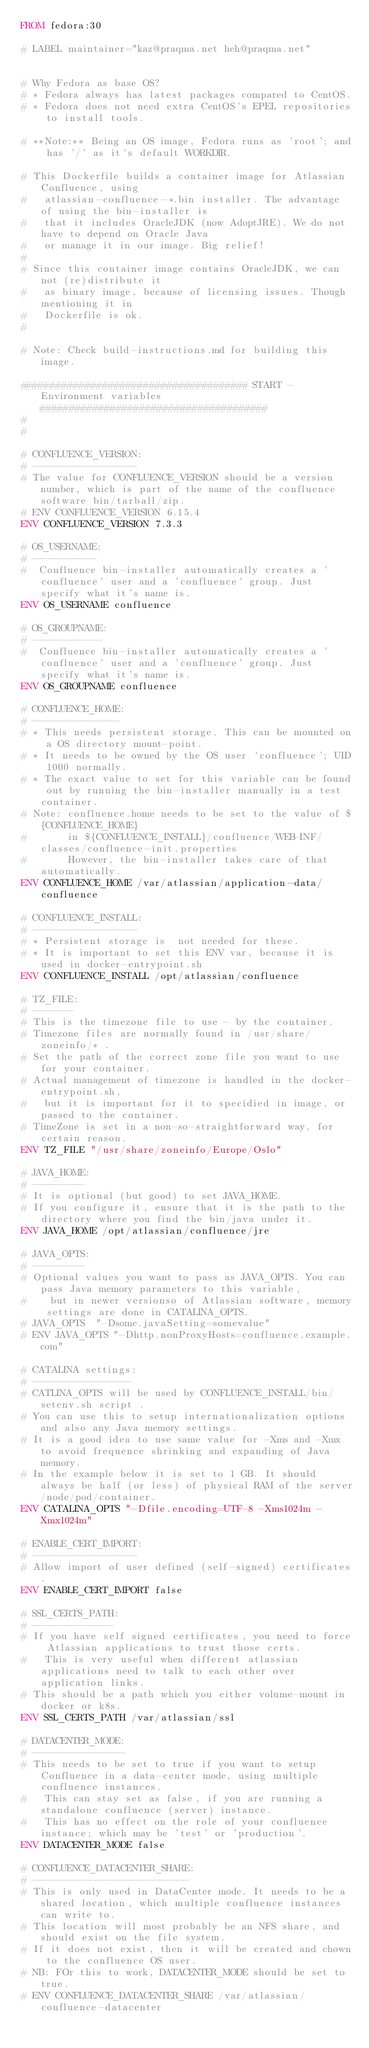<code> <loc_0><loc_0><loc_500><loc_500><_Dockerfile_>FROM fedora:30

# LABEL maintainer="kaz@praqma.net heh@praqma.net"


# Why Fedora as base OS?
# * Fedora always has latest packages compared to CentOS.
# * Fedora does not need extra CentOS's EPEL repositories to install tools.

# **Note:** Being an OS image, Fedora runs as 'root'; and has '/' as it's default WORKDIR.

# This Dockerfile builds a container image for Atlassian Confluence, using 
#   atlassian-confluence-*.bin installer. The advantage of using the bin-installer is
#   that it includes OracleJDK (now AdoptJRE). We do not have to depend on Oracle Java 
#   or manage it in our image. Big relief!
#
# Since this container image contains OracleJDK, we can not (re)distribute it 
#   as binary image, because of licensing issues. Though mentioning it in 
#   Dockerfile is ok.
#

# Note: Check build-instructions.md for building this image.

####################################### START -  Environment variables #######################################
#
#

# CONFLUENCE_VERSION:
# ------------------
# The value for CONFLUENCE_VERSION should be a version number, which is part of the name of the confluence software bin/tarball/zip.
# ENV CONFLUENCE_VERSION 6.15.4
ENV CONFLUENCE_VERSION 7.3.3

# OS_USERNAME:
# -----------
#  Confluence bin-installer automatically creates a 'confluence' user and a 'confluence' group. Just specify what it's name is.
ENV OS_USERNAME confluence

# OS_GROUPNAME:
# ------------
#  Confluence bin-installer automatically creates a 'confluence' user and a 'confluence' group. Just specify what it's name is.
ENV OS_GROUPNAME confluence

# CONFLUENCE_HOME:
# ---------------
# * This needs persistent storage. This can be mounted on a OS directory mount-point.
# * It needs to be owned by the OS user 'confluence'; UID 1000 normally.
# * The exact value to set for this variable can be found out by running the bin-installer manually in a test container.
# Note: confluence.home needs to be set to the value of ${CONFLUENCE_HOME}
#       in ${CONFLUENCE_INSTALL}/confluence/WEB-INF/classes/confluence-init.properties
#       However, the bin-installer takes care of that automatically.
ENV CONFLUENCE_HOME /var/atlassian/application-data/confluence

# CONFLUENCE_INSTALL:
# ------------------
# * Persistent storage is  not needed for these.
# * It is important to set this ENV var, because it is used in docker-entrypoint.sh
ENV CONFLUENCE_INSTALL /opt/atlassian/confluence

# TZ_FILE:
# -------
# This is the timezone file to use - by the container.
# Timezone files are normally found in /usr/share/zoneinfo/* .
# Set the path of the correct zone file you want to use for your container.
# Actual management of timezone is handled in the docker-entrypoint.sh,
#   but it is important for it to specidied in image, or passed to the container.
# TimeZone is set in a non-so-straightforward way, for certain reason.
ENV TZ_FILE "/usr/share/zoneinfo/Europe/Oslo"

# JAVA_HOME:
# ---------
# It is optional (but good) to set JAVA_HOME.
# If you configure it, ensure that it is the path to the directory where you find the bin/java under it.
ENV JAVA_HOME /opt/atlassian/confluence/jre

# JAVA_OPTS:
# ---------
# Optional values you want to pass as JAVA_OPTS. You can pass Java memory parameters to this variable,
#    but in newer versionso of Atlassian software, memory settings are done in CATALINA_OPTS.
# JAVA_OPTS  "-Dsome.javaSetting=somevalue"
# ENV JAVA_OPTS "-Dhttp.nonProxyHosts=confluence.example.com"

# CATALINA settings:
# -----------------
# CATLINA_OPTS will be used by CONFLUENCE_INSTALL/bin/setenv.sh script .
# You can use this to setup internationalization options and also any Java memory settings.
# It is a good idea to use same value for -Xms and -Xmx to avoid frequence shrinking and expanding of Java memory.
# In the example below it is set to 1 GB. It should always be half (or less) of physical RAM of the server/node/pod/container.
ENV CATALINA_OPTS "-Dfile.encoding=UTF-8 -Xms1024m -Xmx1024m"

# ENABLE_CERT_IMPORT:
# ------------------ 
# Allow import of user defined (self-signed) certificates.
ENV ENABLE_CERT_IMPORT false

# SSL_CERTS_PATH:
# --------------
# If you have self signed certificates, you need to force Atlassian applications to trust those certs.
#   This is very useful when different atlassian applications need to talk to each other over application links.
# This should be a path which you either volume-mount in docker or k8s.
ENV SSL_CERTS_PATH /var/atlassian/ssl

# DATACENTER_MODE:
# ----------------
# This needs to be set to true if you want to setup Confluence in a data-center mode, using multiple confluence instances. 
#   This can stay set as false, if you are running a standalone confluence (server) instance. 
#   This has no effect on the role of your confluence instance; which may be 'test' or 'production'.
ENV DATACENTER_MODE false

# CONFLUENCE_DATACENTER_SHARE:
# ---------------------------
# This is only used in DataCenter mode. It needs to be a shared location, which multiple confluence instances can write to.
# This location will most probably be an NFS share, and should exist on the file system.
# If it does not exist, then it will be created and chown to the confluence OS user.
# NB: FOr this to work, DATACENTER_MODE should be set to true.
# ENV CONFLUENCE_DATACENTER_SHARE /var/atlassian/confluence-datacenter</code> 